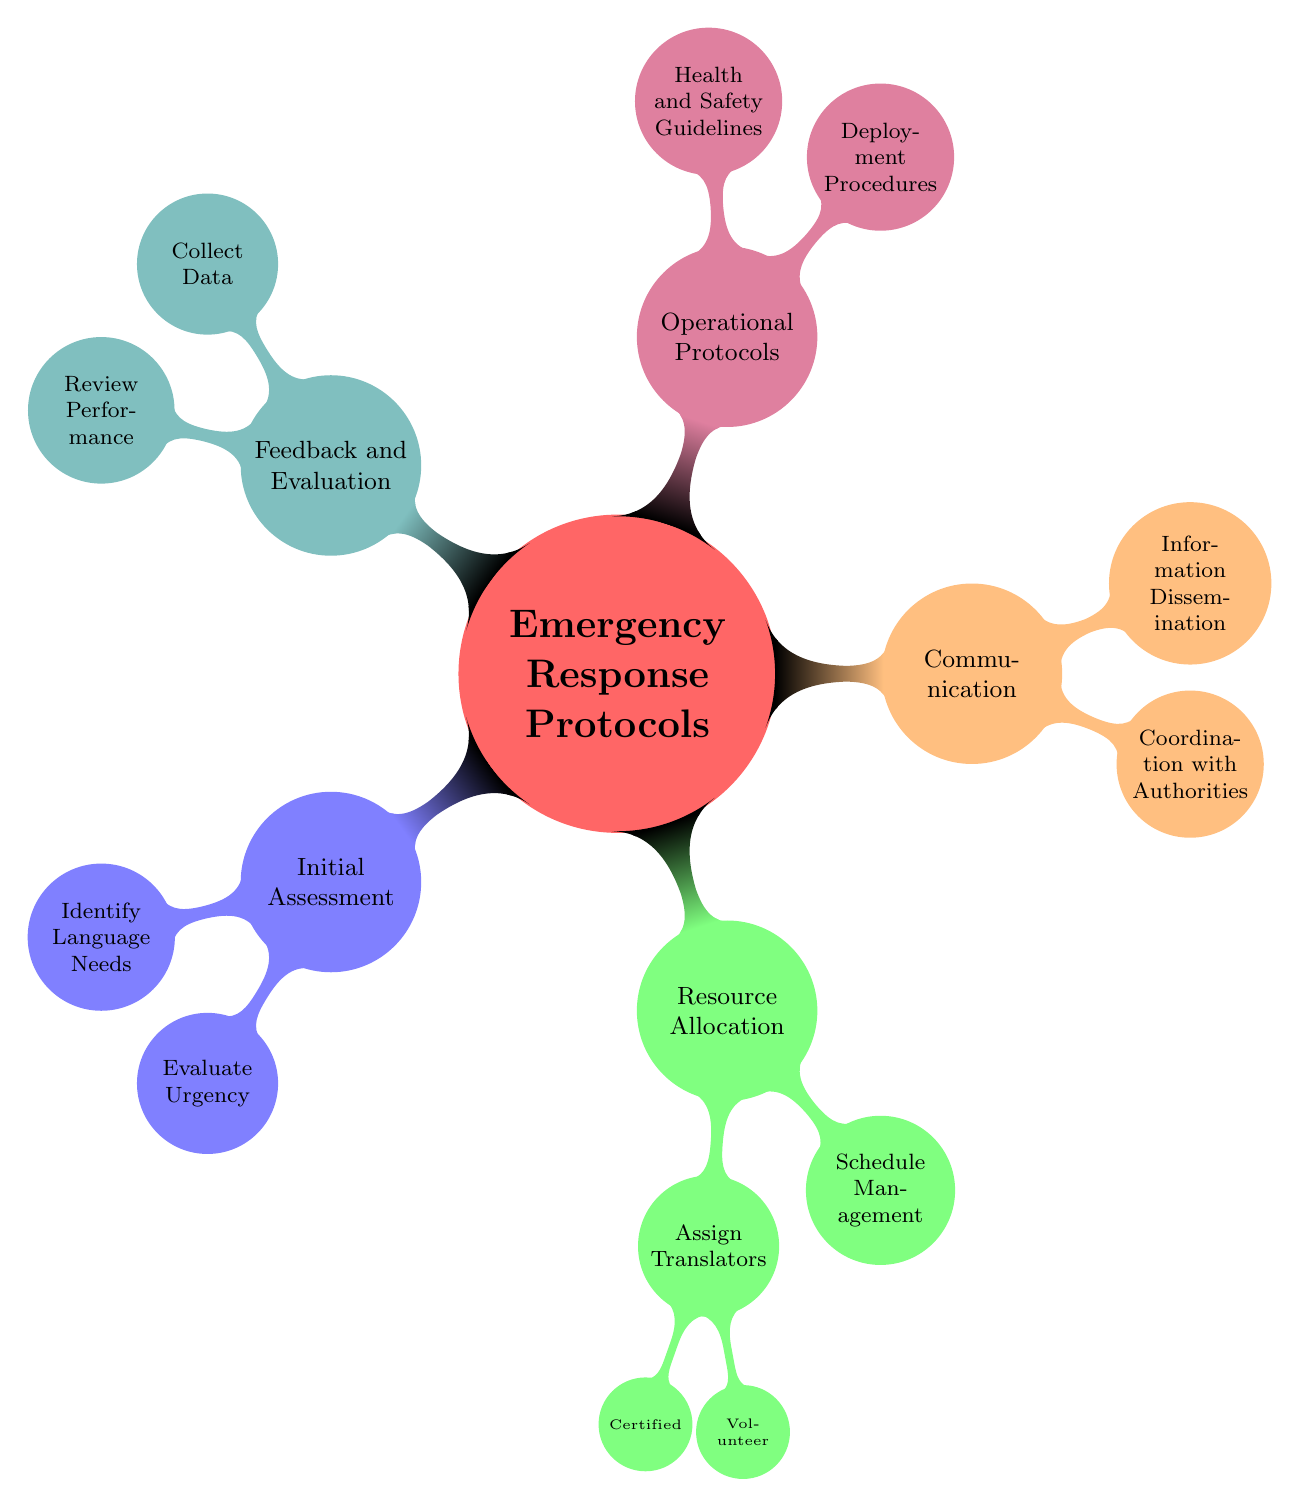What are the main categories of Emergency Response Protocols? The mind map outlines five main categories related to Emergency Response Protocols: Initial Assessment, Resource Allocation, Communication, Operational Protocols, and Feedback and Evaluation.
Answer: Initial Assessment, Resource Allocation, Communication, Operational Protocols, Feedback and Evaluation How many subcategories are under Resource Allocation? The Resource Allocation category contains three subcategories: Assign Translators, which further divides into Certified and Volunteer Translators, and Schedule Management. Therefore, the total count of direct subcategories is three.
Answer: 3 What needs to be assessed during the Initial Assessment phase? In the Initial Assessment phase, the needs addressed include Identify Language Needs and Evaluate Urgency. Both are critical to understanding the translation requirements for coordination.
Answer: Identify Language Needs, Evaluate Urgency Which subcategory under Resource Allocation involves assigning translators? The subcategory that involves assigning translators is called Assign Translators, which includes both Certified Translators and Volunteer Translators as further divisions.
Answer: Assign Translators What two aspects are covered under Communication? The Communication category contains two aspects: Coordination with Authorities and Information Dissemination, which are important for ensuring effective communication during emergencies.
Answer: Coordination with Authorities, Information Dissemination How does Feedback and Evaluation contribute to the overall process? Feedback and Evaluation contributes by collecting data through the Collect Data subcategory and reviewing performance through the Review Performance subcategory, ensuring ongoing improvement.
Answer: Collect Data, Review Performance Which category includes Deployment Procedures? The category that includes Deployment Procedures is Operational Protocols, which is essential to outline the guidelines for how translation services are deployed during an emergency situation.
Answer: Operational Protocols What is the relationship between feedback and data collection? Feedback relates to data collection as the Collect Data subcategory gathers information necessary for reviewing performance, facilitating improvements in future response efforts.
Answer: Collect Data and Review Performance 